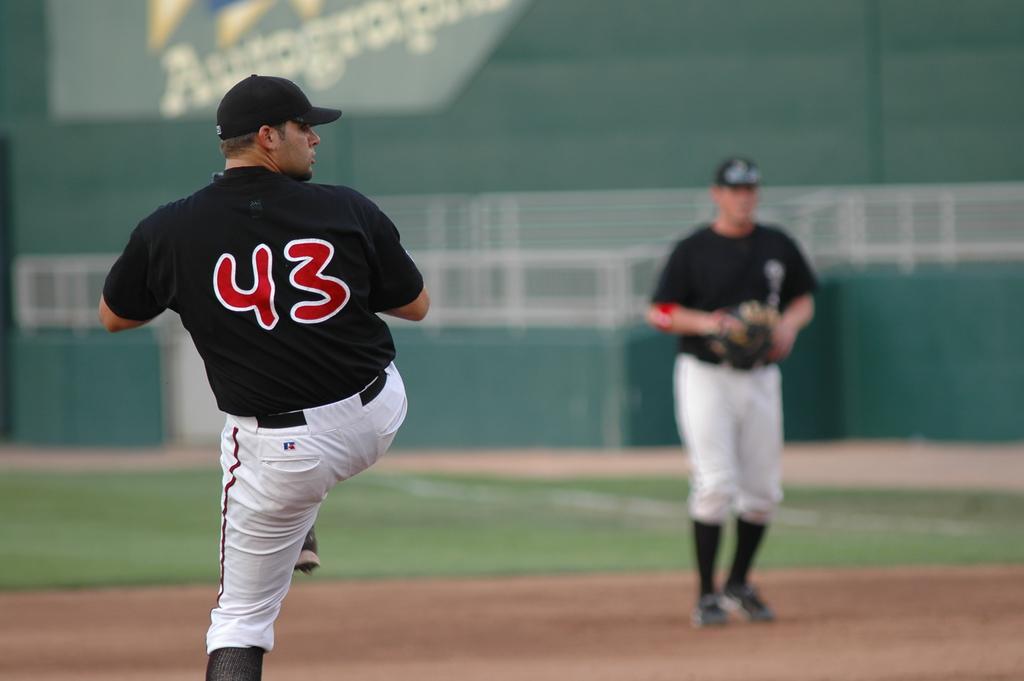What number player has his leg up?
Provide a succinct answer. 43. 